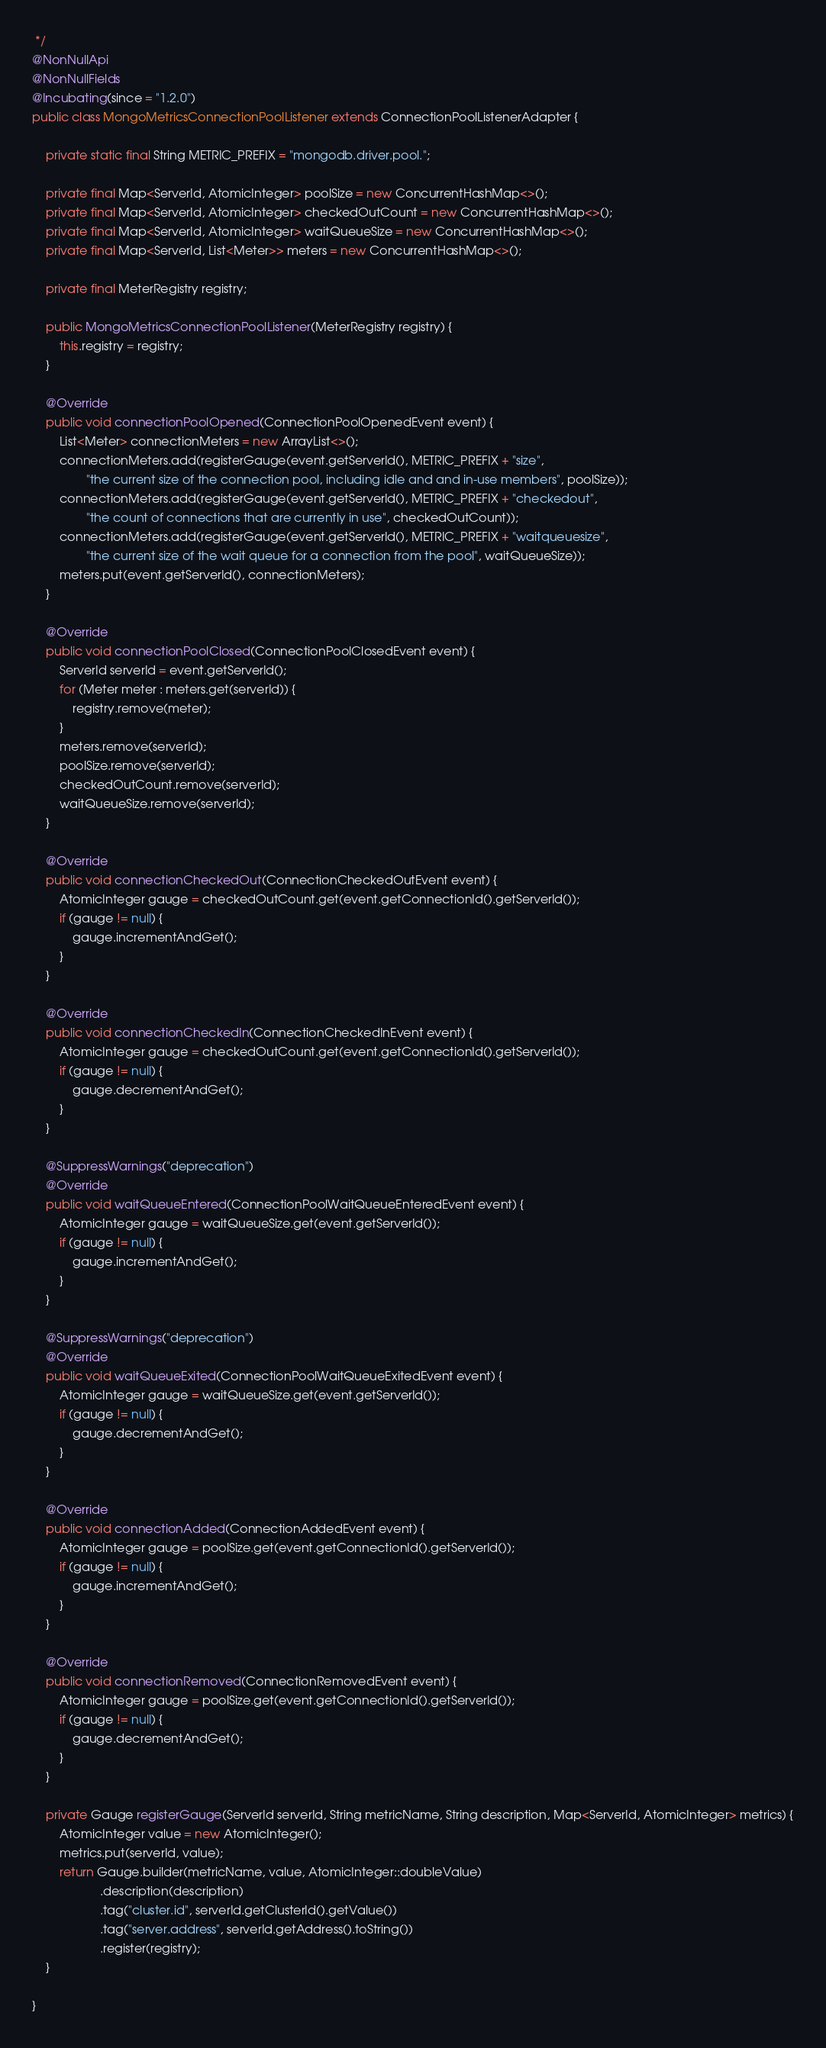Convert code to text. <code><loc_0><loc_0><loc_500><loc_500><_Java_> */
@NonNullApi
@NonNullFields
@Incubating(since = "1.2.0")
public class MongoMetricsConnectionPoolListener extends ConnectionPoolListenerAdapter {

    private static final String METRIC_PREFIX = "mongodb.driver.pool.";

    private final Map<ServerId, AtomicInteger> poolSize = new ConcurrentHashMap<>();
    private final Map<ServerId, AtomicInteger> checkedOutCount = new ConcurrentHashMap<>();
    private final Map<ServerId, AtomicInteger> waitQueueSize = new ConcurrentHashMap<>();
    private final Map<ServerId, List<Meter>> meters = new ConcurrentHashMap<>();

    private final MeterRegistry registry;

    public MongoMetricsConnectionPoolListener(MeterRegistry registry) {
        this.registry = registry;
    }

    @Override
    public void connectionPoolOpened(ConnectionPoolOpenedEvent event) {
        List<Meter> connectionMeters = new ArrayList<>();
        connectionMeters.add(registerGauge(event.getServerId(), METRIC_PREFIX + "size",
                "the current size of the connection pool, including idle and and in-use members", poolSize));
        connectionMeters.add(registerGauge(event.getServerId(), METRIC_PREFIX + "checkedout",
                "the count of connections that are currently in use", checkedOutCount));
        connectionMeters.add(registerGauge(event.getServerId(), METRIC_PREFIX + "waitqueuesize",
                "the current size of the wait queue for a connection from the pool", waitQueueSize));
        meters.put(event.getServerId(), connectionMeters);
    }

    @Override
    public void connectionPoolClosed(ConnectionPoolClosedEvent event) {
        ServerId serverId = event.getServerId();
        for (Meter meter : meters.get(serverId)) {
            registry.remove(meter);
        }
        meters.remove(serverId);
        poolSize.remove(serverId);
        checkedOutCount.remove(serverId);
        waitQueueSize.remove(serverId);
    }

    @Override
    public void connectionCheckedOut(ConnectionCheckedOutEvent event) {
        AtomicInteger gauge = checkedOutCount.get(event.getConnectionId().getServerId());
        if (gauge != null) {
            gauge.incrementAndGet();
        }
    }

    @Override
    public void connectionCheckedIn(ConnectionCheckedInEvent event) {
        AtomicInteger gauge = checkedOutCount.get(event.getConnectionId().getServerId());
        if (gauge != null) {
            gauge.decrementAndGet();
        }
    }

    @SuppressWarnings("deprecation")
    @Override
    public void waitQueueEntered(ConnectionPoolWaitQueueEnteredEvent event) {
        AtomicInteger gauge = waitQueueSize.get(event.getServerId());
        if (gauge != null) {
            gauge.incrementAndGet();
        }
    }

    @SuppressWarnings("deprecation")
    @Override
    public void waitQueueExited(ConnectionPoolWaitQueueExitedEvent event) {
        AtomicInteger gauge = waitQueueSize.get(event.getServerId());
        if (gauge != null) {
            gauge.decrementAndGet();
        }
    }

    @Override
    public void connectionAdded(ConnectionAddedEvent event) {
        AtomicInteger gauge = poolSize.get(event.getConnectionId().getServerId());
        if (gauge != null) {
            gauge.incrementAndGet();
        }
    }

    @Override
    public void connectionRemoved(ConnectionRemovedEvent event) {
        AtomicInteger gauge = poolSize.get(event.getConnectionId().getServerId());
        if (gauge != null) {
            gauge.decrementAndGet();
        }
    }

    private Gauge registerGauge(ServerId serverId, String metricName, String description, Map<ServerId, AtomicInteger> metrics) {
        AtomicInteger value = new AtomicInteger();
        metrics.put(serverId, value);
        return Gauge.builder(metricName, value, AtomicInteger::doubleValue)
                    .description(description)
                    .tag("cluster.id", serverId.getClusterId().getValue())
                    .tag("server.address", serverId.getAddress().toString())
                    .register(registry);
    }

}
</code> 